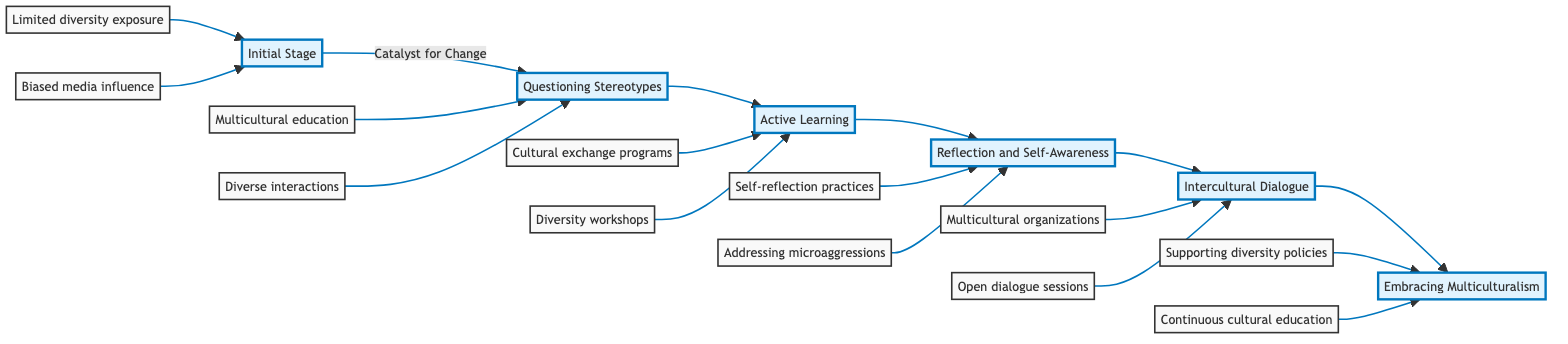What is the first stage of personal growth? The first stage in the flowchart is labeled "Initial Stage," which describes a closed-minded individual influenced by stereotypes. This is visually depicted as the starting point in the flowchart.
Answer: Initial Stage How many key factors are listed under the "Intercultural Dialogue" stage? In the "Intercultural Dialogue" stage, there are three key factors listed: joining multicultural organizations, facilitating open dialogue sessions, and practicing active listening and empathy.
Answer: 3 What comes after "Active Learning" in the flowchart? The flowchart shows that after the "Active Learning" stage, the next sequential stage is "Reflection and Self-Awareness," indicating the progression in personal growth.
Answer: Reflection and Self-Awareness What is a key factor in the "Catalyst for Change" stage? A key factor listed in the "Catalyst for Change" stage is "Exposure to multicultural education through coursework," representing an important aspect that leads to questioning stereotypes.
Answer: Exposure to multicultural education through coursework How many total stages are present in the diagram? By counting the distinct stages from "Initial Stage" to "Embracing Multiculturalism," I identify six stages, resulting in a total of six sequential steps in the personal growth path.
Answer: 6 What role do self-reflection practices play in the personal growth path? Self-reflection practices appear under the "Reflection and Self-Awareness" stage and are crucial for recognizing and challenging one's biases, contributing significantly to personal growth.
Answer: Recognizing and challenging biases Describe the relationship between the "Initial Stage" and the "Catalyst for Change." The "Initial Stage" leads into the "Catalyst for Change," indicating that personal stagnation characterized by stereotyping can be transformed by experiences that prompt questioning of those stereotypes.
Answer: Progression to questioning stereotypes What is the final stage of the personal growth path? The final stage in the horizontal flowchart, representing the culmination of the growth path, is "Embracing Multiculturalism," which implies full adoption of inclusivity and diversity.
Answer: Embracing Multiculturalism What is a common outcome of engaging in "Active Learning"? Engaging in "Active Learning," specifically participating in cultural exchange programs, typically results in a deeper understanding of diverse cultures, which is depicted as an active reconstruction of one's mindset.
Answer: Deeper understanding of diverse cultures 